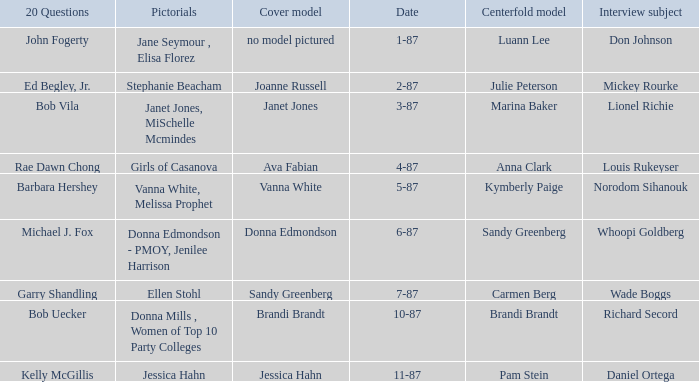When was the Kymberly Paige the Centerfold? 5-87. 